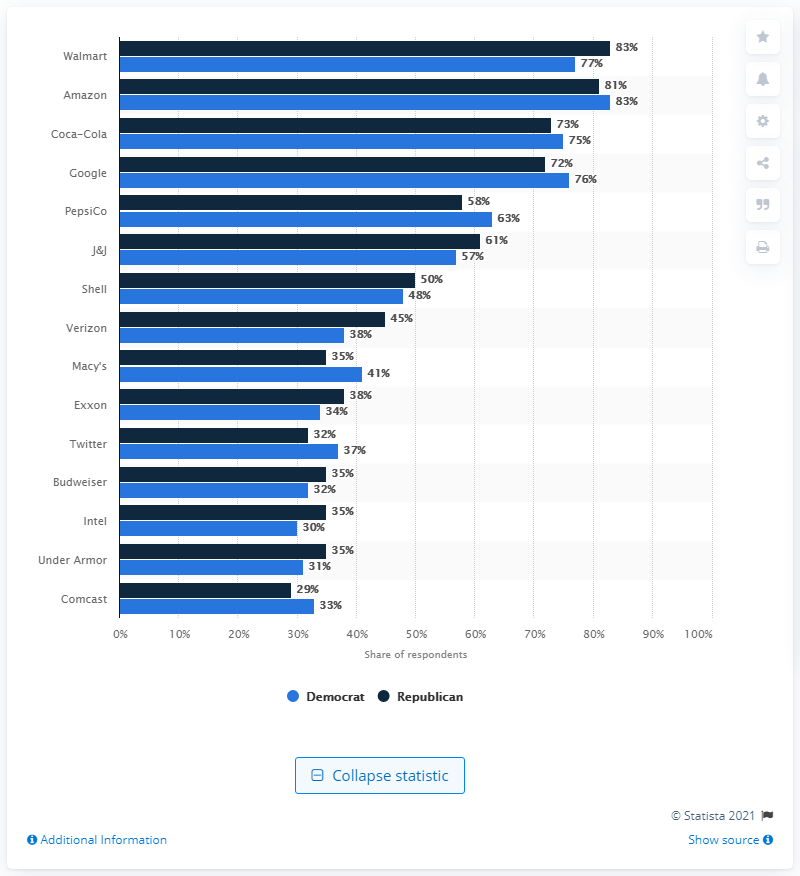Highlight a few significant elements in this photo. The majority of Republicans, 83%, preferred the brand Walmart. 